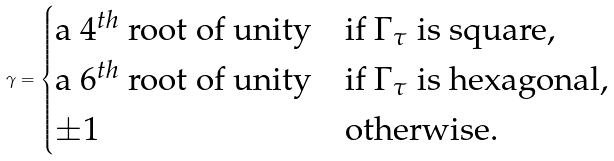<formula> <loc_0><loc_0><loc_500><loc_500>\gamma = \begin{cases} \text {a $4^{th}$ root of unity} & \text {if $\Gamma _{\tau }$ is square,} \\ \text {a $6^{th}$ root of unity} & \text {if $\Gamma _{\tau }$ is hexagonal,} \\ \pm 1 & \text {otherwise.} \\ \end{cases}</formula> 